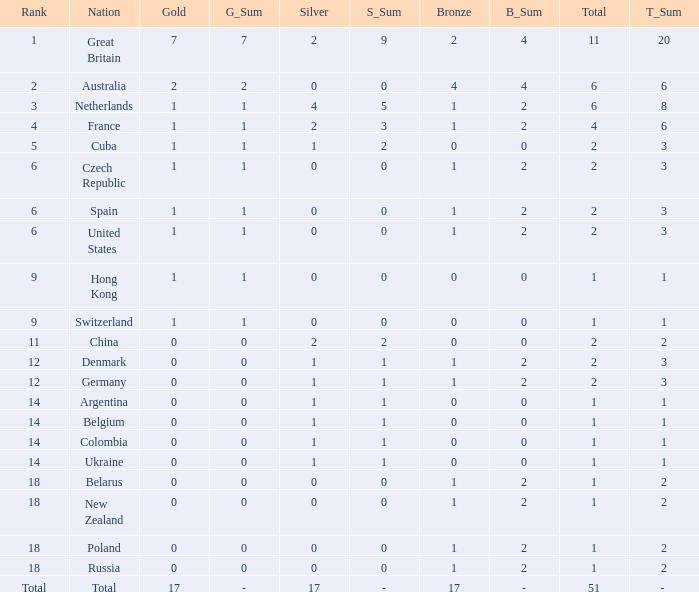Tell me the rank for bronze less than 17 and gold less than 1 11.0. 